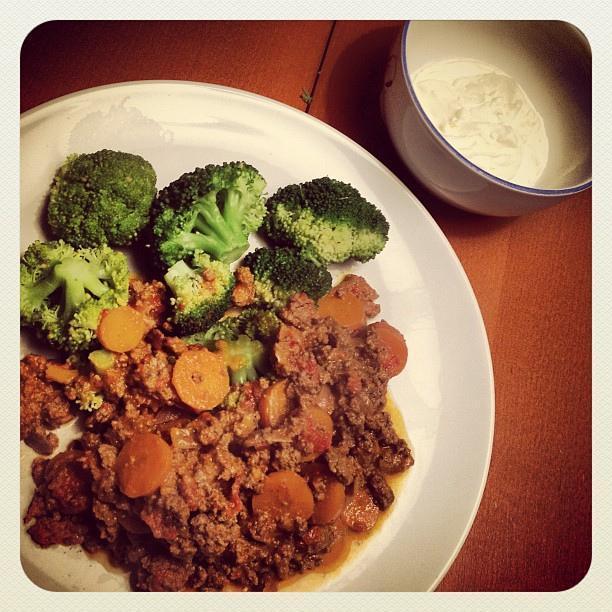How many broccolis are in the photo?
Give a very brief answer. 6. How many carrots are in the photo?
Give a very brief answer. 4. 